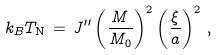Convert formula to latex. <formula><loc_0><loc_0><loc_500><loc_500>k _ { B } T _ { \text {N} } \, = \, J ^ { \prime \prime } \left ( \frac { M } { M _ { 0 } } \right ) ^ { 2 } \left ( \frac { \xi } { a } \right ) ^ { 2 } \, ,</formula> 